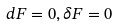<formula> <loc_0><loc_0><loc_500><loc_500>d F = 0 , \delta F = 0</formula> 